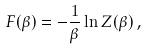Convert formula to latex. <formula><loc_0><loc_0><loc_500><loc_500>F ( \beta ) = - \frac { 1 } { \beta } \ln Z ( \beta ) \, ,</formula> 